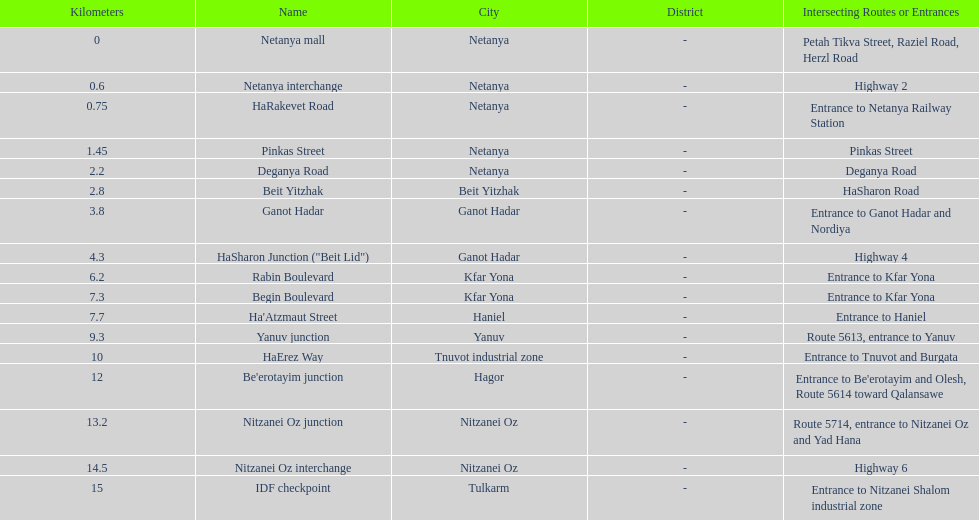Which portion has the same intersecting route as rabin boulevard? Begin Boulevard. 